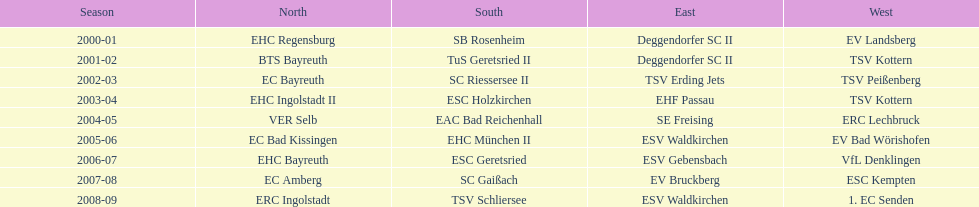What is the number of times deggendorfer sc ii is on the list? 2. 